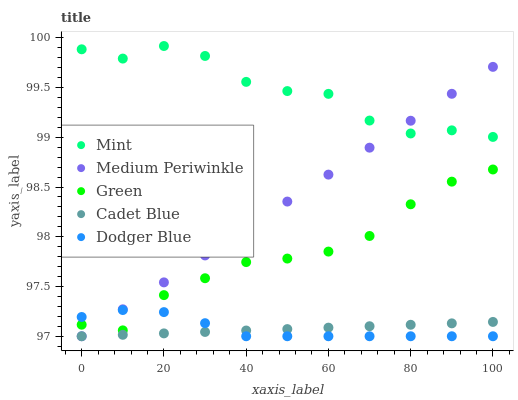Does Cadet Blue have the minimum area under the curve?
Answer yes or no. Yes. Does Mint have the maximum area under the curve?
Answer yes or no. Yes. Does Medium Periwinkle have the minimum area under the curve?
Answer yes or no. No. Does Medium Periwinkle have the maximum area under the curve?
Answer yes or no. No. Is Cadet Blue the smoothest?
Answer yes or no. Yes. Is Mint the roughest?
Answer yes or no. Yes. Is Medium Periwinkle the smoothest?
Answer yes or no. No. Is Medium Periwinkle the roughest?
Answer yes or no. No. Does Cadet Blue have the lowest value?
Answer yes or no. Yes. Does Green have the lowest value?
Answer yes or no. No. Does Mint have the highest value?
Answer yes or no. Yes. Does Medium Periwinkle have the highest value?
Answer yes or no. No. Is Green less than Mint?
Answer yes or no. Yes. Is Green greater than Cadet Blue?
Answer yes or no. Yes. Does Medium Periwinkle intersect Cadet Blue?
Answer yes or no. Yes. Is Medium Periwinkle less than Cadet Blue?
Answer yes or no. No. Is Medium Periwinkle greater than Cadet Blue?
Answer yes or no. No. Does Green intersect Mint?
Answer yes or no. No. 